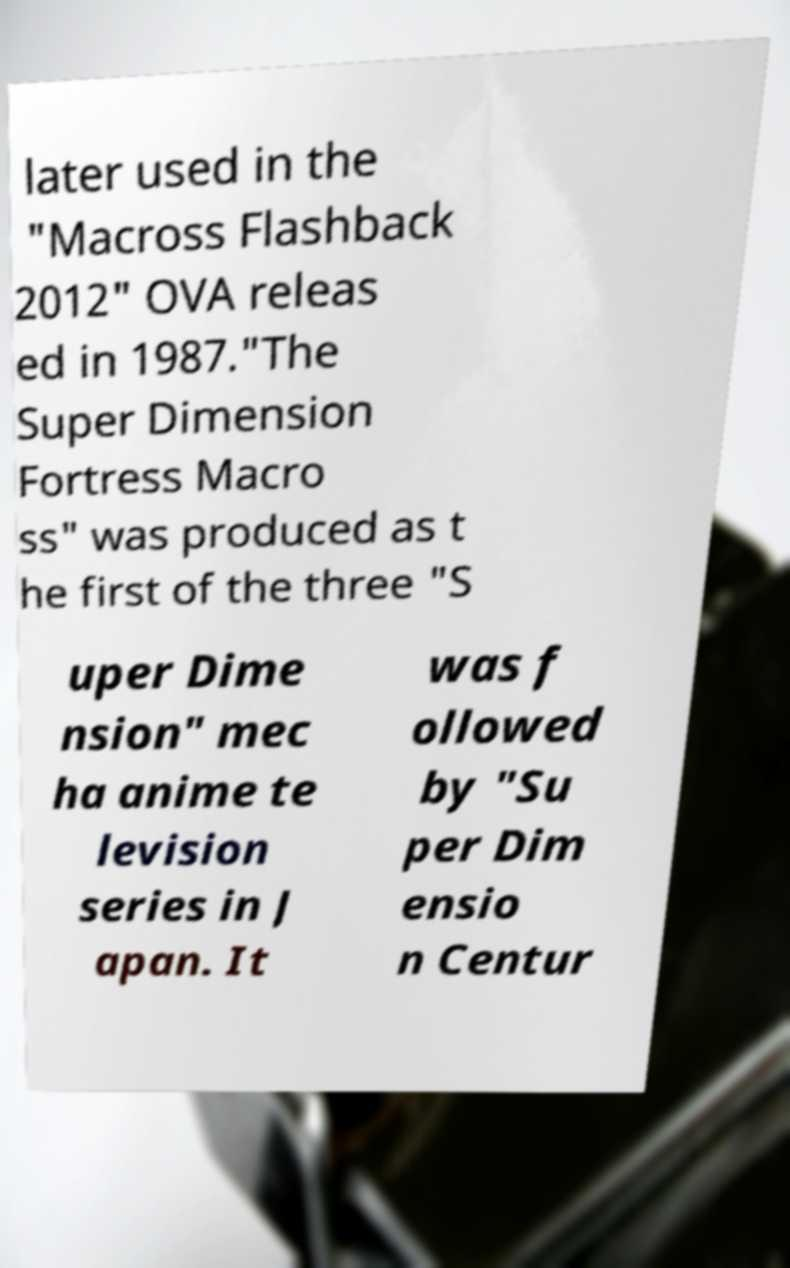What messages or text are displayed in this image? I need them in a readable, typed format. later used in the "Macross Flashback 2012" OVA releas ed in 1987."The Super Dimension Fortress Macro ss" was produced as t he first of the three "S uper Dime nsion" mec ha anime te levision series in J apan. It was f ollowed by "Su per Dim ensio n Centur 